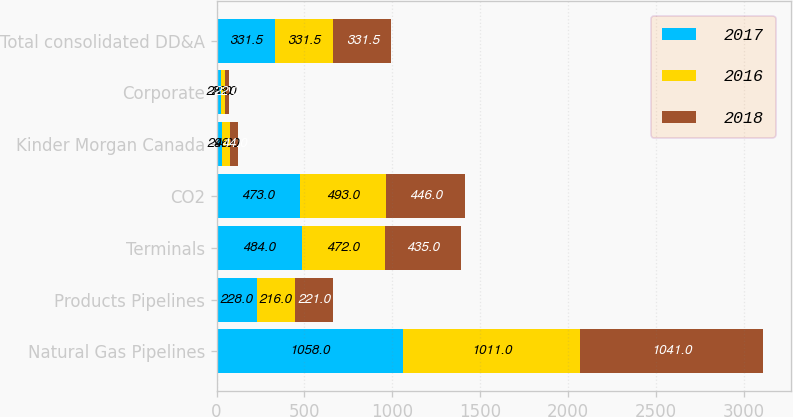Convert chart to OTSL. <chart><loc_0><loc_0><loc_500><loc_500><stacked_bar_chart><ecel><fcel>Natural Gas Pipelines<fcel>Products Pipelines<fcel>Terminals<fcel>CO2<fcel>Kinder Morgan Canada<fcel>Corporate<fcel>Total consolidated DD&A<nl><fcel>2017<fcel>1058<fcel>228<fcel>484<fcel>473<fcel>29<fcel>25<fcel>331.5<nl><fcel>2016<fcel>1011<fcel>216<fcel>472<fcel>493<fcel>46<fcel>23<fcel>331.5<nl><fcel>2018<fcel>1041<fcel>221<fcel>435<fcel>446<fcel>44<fcel>22<fcel>331.5<nl></chart> 